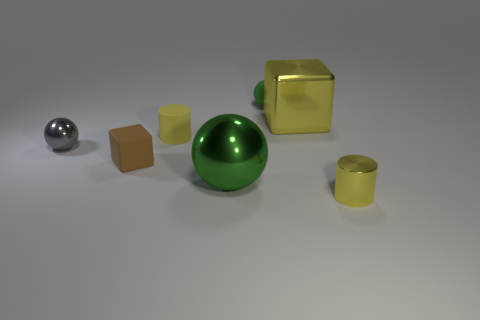There is a green thing that is the same material as the small gray ball; what is its size? The green object is a large, shiny sphere that appears to be roughly twice the diameter of the small gray ball. 